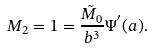<formula> <loc_0><loc_0><loc_500><loc_500>M _ { 2 } = 1 = \frac { \tilde { M } _ { 0 } } { b ^ { 3 } } \Psi ^ { ^ { \prime } } ( a ) .</formula> 